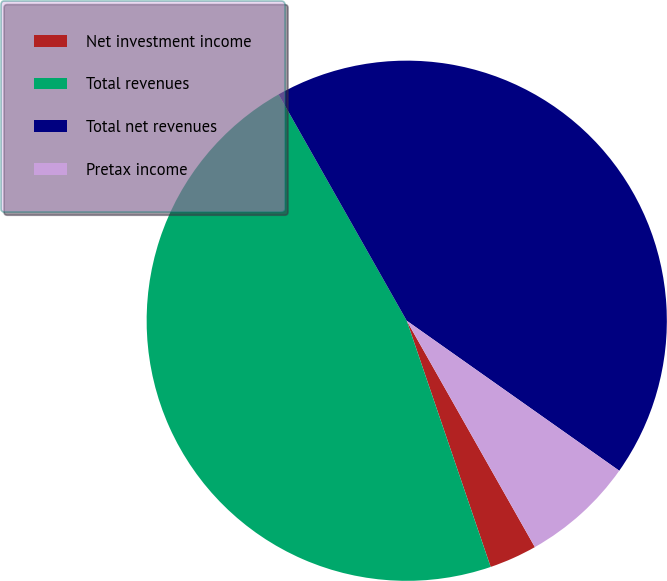Convert chart. <chart><loc_0><loc_0><loc_500><loc_500><pie_chart><fcel>Net investment income<fcel>Total revenues<fcel>Total net revenues<fcel>Pretax income<nl><fcel>2.97%<fcel>47.03%<fcel>42.98%<fcel>7.02%<nl></chart> 